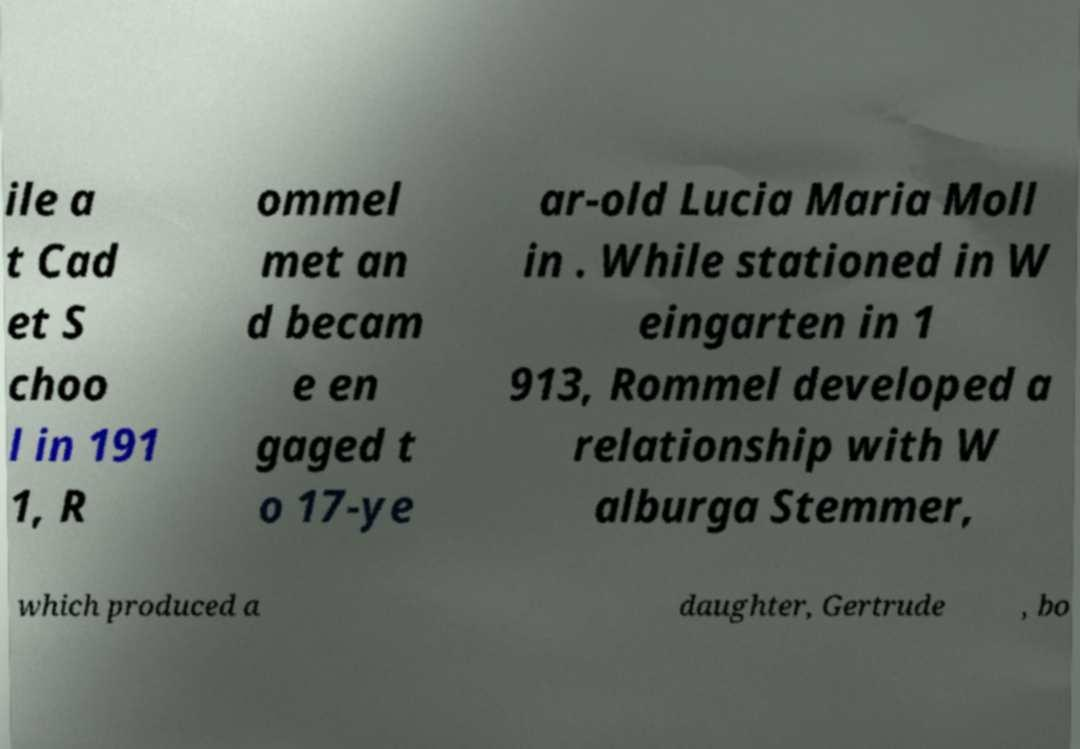Please read and relay the text visible in this image. What does it say? ile a t Cad et S choo l in 191 1, R ommel met an d becam e en gaged t o 17-ye ar-old Lucia Maria Moll in . While stationed in W eingarten in 1 913, Rommel developed a relationship with W alburga Stemmer, which produced a daughter, Gertrude , bo 